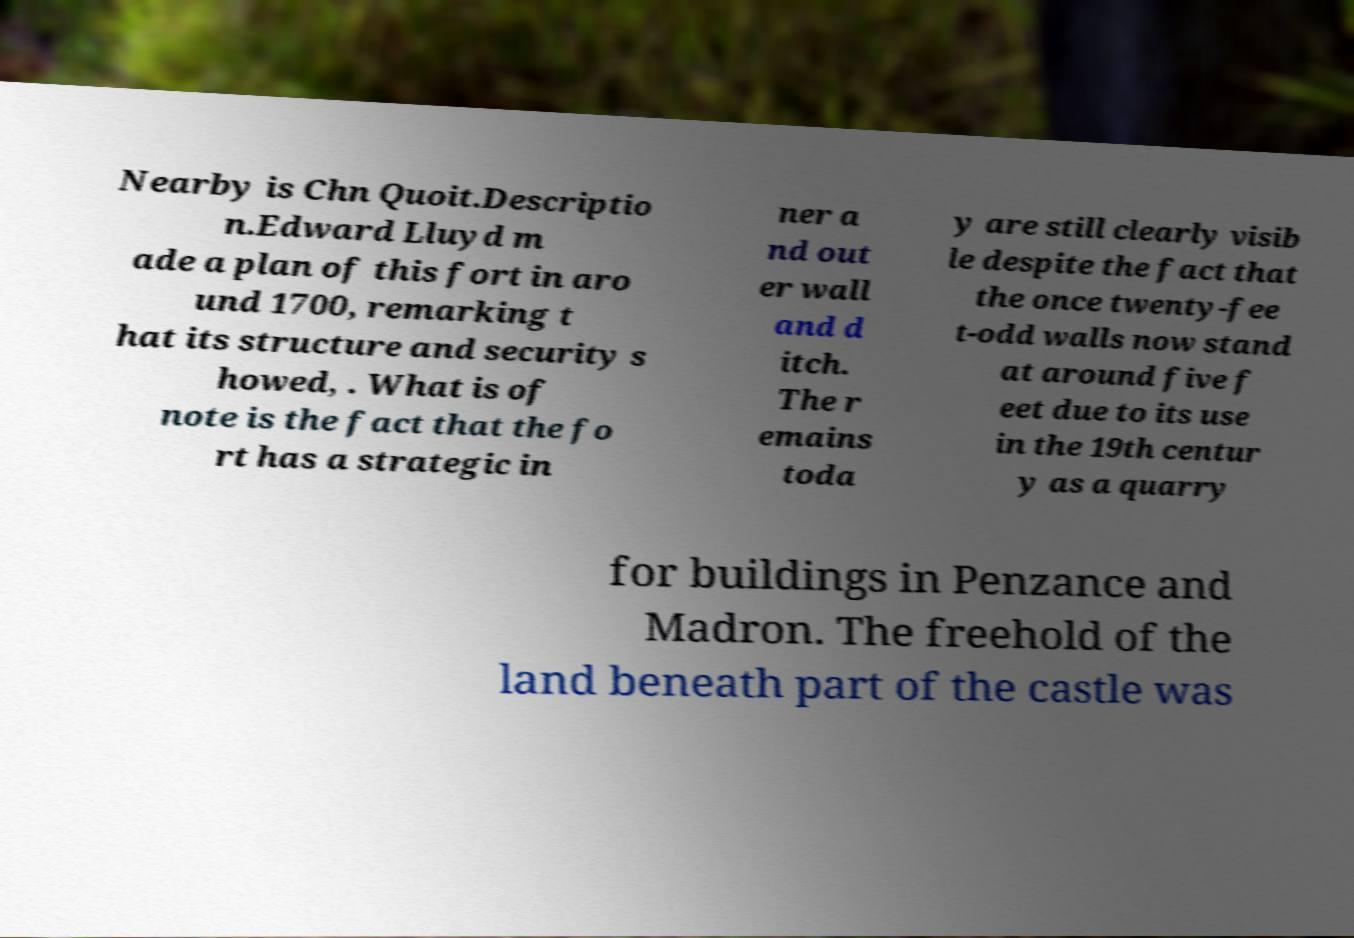Please read and relay the text visible in this image. What does it say? Nearby is Chn Quoit.Descriptio n.Edward Lluyd m ade a plan of this fort in aro und 1700, remarking t hat its structure and security s howed, . What is of note is the fact that the fo rt has a strategic in ner a nd out er wall and d itch. The r emains toda y are still clearly visib le despite the fact that the once twenty-fee t-odd walls now stand at around five f eet due to its use in the 19th centur y as a quarry for buildings in Penzance and Madron. The freehold of the land beneath part of the castle was 